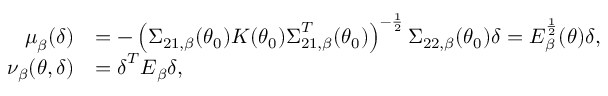Convert formula to latex. <formula><loc_0><loc_0><loc_500><loc_500>\begin{array} { r l } { \mu _ { \beta } ( \delta ) } & { = - \left ( \Sigma _ { 2 1 , \beta } ( \theta _ { 0 } ) K ( \theta _ { 0 } ) \Sigma _ { 2 1 , \beta } ^ { T } ( \theta _ { 0 } ) \right ) ^ { - \frac { 1 } { 2 } } \Sigma _ { 2 2 , \beta } ( \theta _ { 0 } ) \delta = E _ { \beta } ^ { \frac { 1 } { 2 } } ( \theta ) \delta , } \\ { \nu _ { \beta } ( \theta , \delta ) } & { = \delta ^ { T } E _ { \beta } \delta , } \end{array}</formula> 